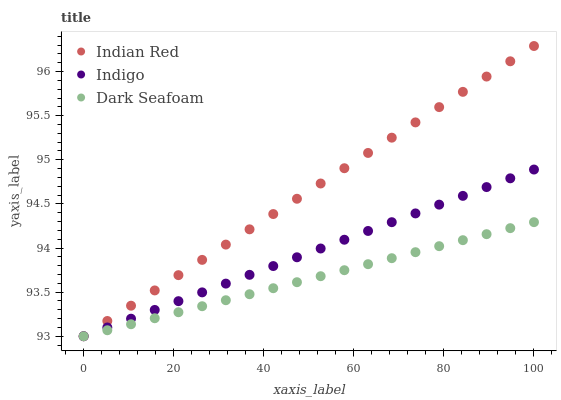Does Dark Seafoam have the minimum area under the curve?
Answer yes or no. Yes. Does Indian Red have the maximum area under the curve?
Answer yes or no. Yes. Does Indigo have the minimum area under the curve?
Answer yes or no. No. Does Indigo have the maximum area under the curve?
Answer yes or no. No. Is Indigo the smoothest?
Answer yes or no. Yes. Is Indian Red the roughest?
Answer yes or no. Yes. Is Indian Red the smoothest?
Answer yes or no. No. Is Indigo the roughest?
Answer yes or no. No. Does Dark Seafoam have the lowest value?
Answer yes or no. Yes. Does Indian Red have the highest value?
Answer yes or no. Yes. Does Indigo have the highest value?
Answer yes or no. No. Does Indigo intersect Indian Red?
Answer yes or no. Yes. Is Indigo less than Indian Red?
Answer yes or no. No. Is Indigo greater than Indian Red?
Answer yes or no. No. 